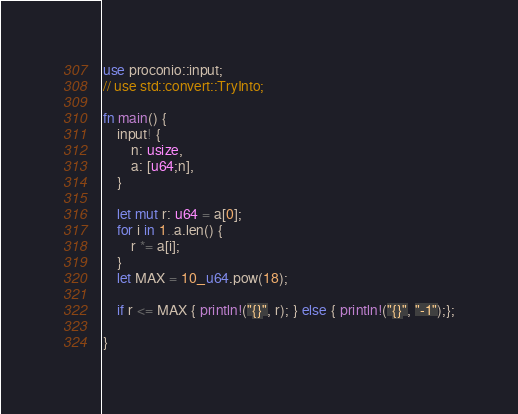<code> <loc_0><loc_0><loc_500><loc_500><_Rust_>use proconio::input;
// use std::convert::TryInto;

fn main() {
    input! {
        n: usize,
        a: [u64;n],
    }

    let mut r: u64 = a[0];
    for i in 1..a.len() {
        r *= a[i];
    }
    let MAX = 10_u64.pow(18);

    if r <= MAX { println!("{}", r); } else { println!("{}", "-1");};

}
</code> 